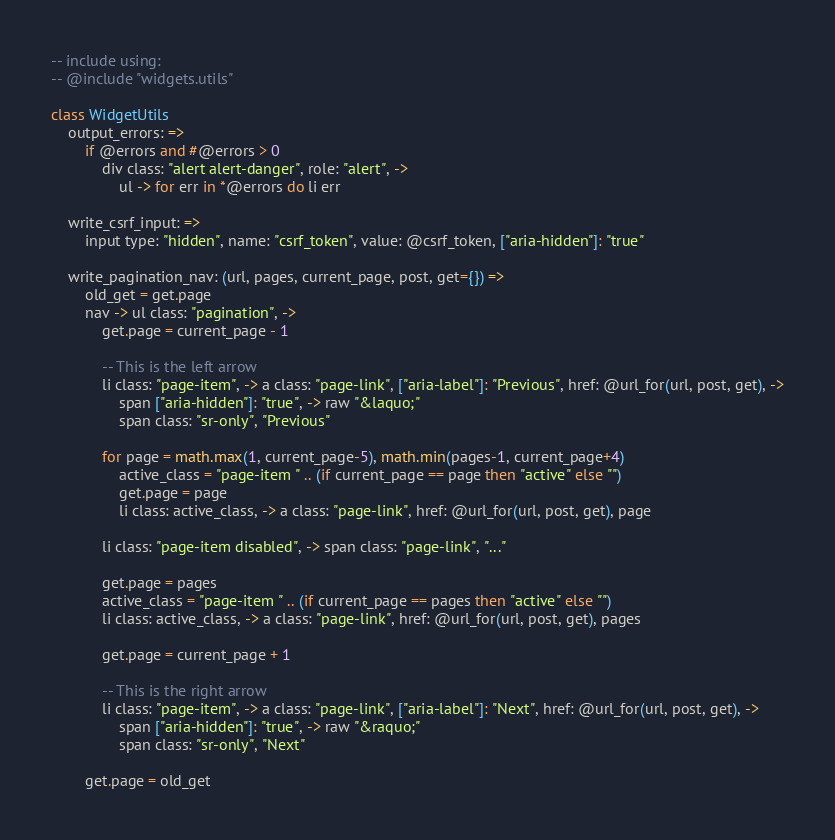<code> <loc_0><loc_0><loc_500><loc_500><_MoonScript_>-- include using:
-- @include "widgets.utils"

class WidgetUtils
	output_errors: =>
		if @errors and #@errors > 0
			div class: "alert alert-danger", role: "alert", ->
				ul -> for err in *@errors do li err

	write_csrf_input: =>
		input type: "hidden", name: "csrf_token", value: @csrf_token, ["aria-hidden"]: "true"

	write_pagination_nav: (url, pages, current_page, post, get={}) =>
		old_get = get.page
		nav -> ul class: "pagination", ->
			get.page = current_page - 1

			-- This is the left arrow
			li class: "page-item", -> a class: "page-link", ["aria-label"]: "Previous", href: @url_for(url, post, get), ->
				span ["aria-hidden"]: "true", -> raw "&laquo;"
				span class: "sr-only", "Previous"

			for page = math.max(1, current_page-5), math.min(pages-1, current_page+4)
				active_class = "page-item " .. (if current_page == page then "active" else "")
				get.page = page
				li class: active_class, -> a class: "page-link", href: @url_for(url, post, get), page

			li class: "page-item disabled", -> span class: "page-link", "..."

			get.page = pages
			active_class = "page-item " .. (if current_page == pages then "active" else "")
			li class: active_class, -> a class: "page-link", href: @url_for(url, post, get), pages
			
			get.page = current_page + 1

			-- This is the right arrow
			li class: "page-item", -> a class: "page-link", ["aria-label"]: "Next", href: @url_for(url, post, get), ->
				span ["aria-hidden"]: "true", -> raw "&raquo;"
				span class: "sr-only", "Next"

		get.page = old_get</code> 